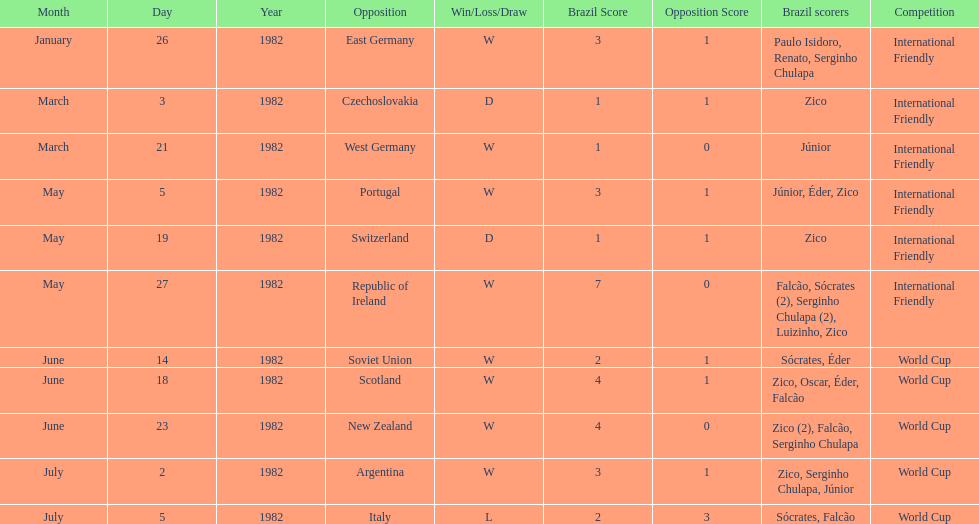Who did brazil play against Soviet Union. Who scored the most goals? Portugal. 